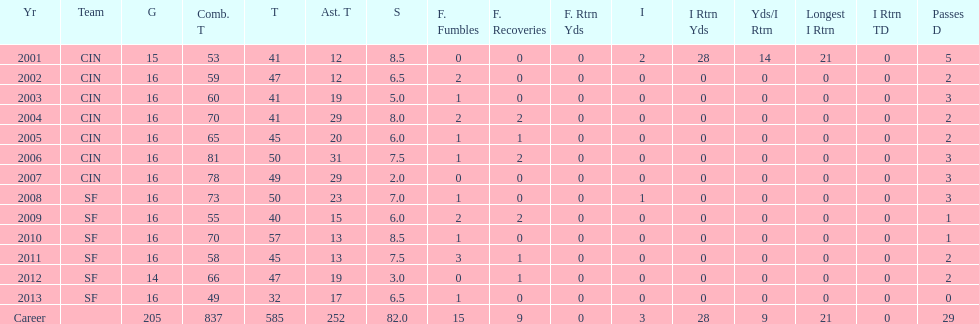How many years did he play where he did not recover a fumble? 7. 